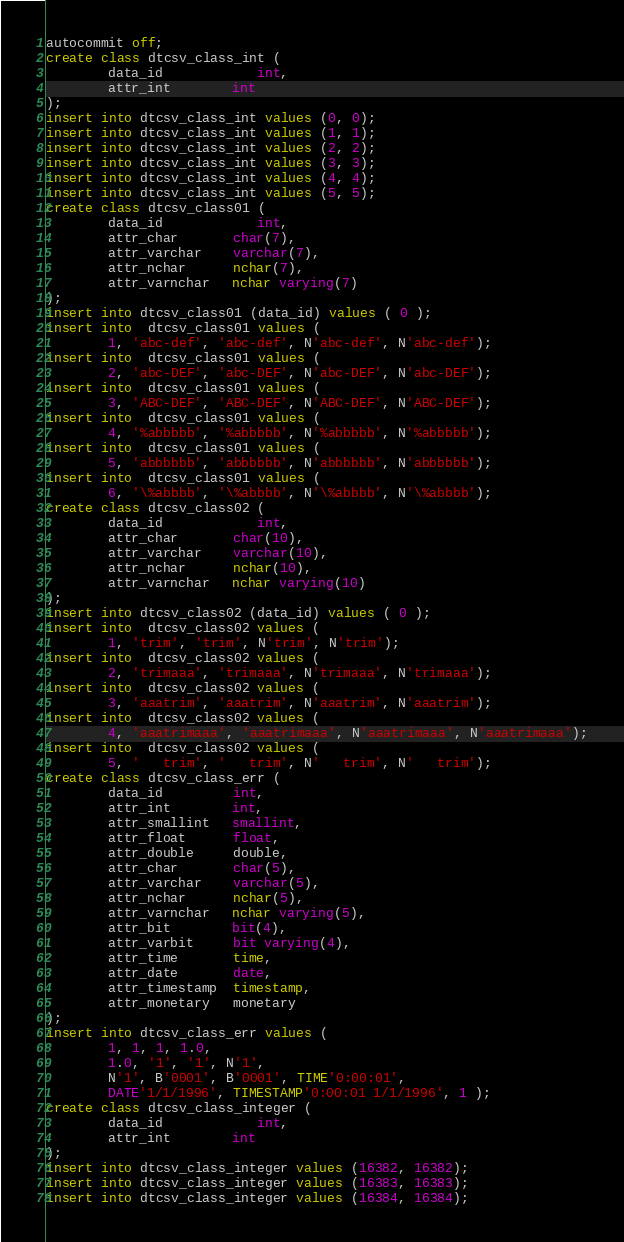Convert code to text. <code><loc_0><loc_0><loc_500><loc_500><_SQL_>autocommit off;
create class dtcsv_class_int (
        data_id        	int,
        attr_int        int
);
insert into dtcsv_class_int values (0, 0);
insert into dtcsv_class_int values (1, 1);
insert into dtcsv_class_int values (2, 2);
insert into dtcsv_class_int values (3, 3);
insert into dtcsv_class_int values (4, 4);
insert into dtcsv_class_int values (5, 5);
create class dtcsv_class01 (
        data_id        	int,
        attr_char       char(7),
        attr_varchar    varchar(7),
        attr_nchar      nchar(7),
        attr_varnchar   nchar varying(7)
);
insert into dtcsv_class01 (data_id) values ( 0 );
insert into  dtcsv_class01 values (
        1, 'abc-def', 'abc-def', N'abc-def', N'abc-def');
insert into  dtcsv_class01 values (
        2, 'abc-DEF', 'abc-DEF', N'abc-DEF', N'abc-DEF');
insert into  dtcsv_class01 values (
        3, 'ABC-DEF', 'ABC-DEF', N'ABC-DEF', N'ABC-DEF');
insert into  dtcsv_class01 values (
        4, '%abbbbb', '%abbbbb', N'%abbbbb', N'%abbbbb');
insert into  dtcsv_class01 values (
        5, 'abbbbbb', 'abbbbbb', N'abbbbbb', N'abbbbbb');
insert into  dtcsv_class01 values (
        6, '\%abbbb', '\%abbbb', N'\%abbbb', N'\%abbbb');
create class dtcsv_class02 (
        data_id        	int,
        attr_char       char(10),
        attr_varchar    varchar(10),
        attr_nchar      nchar(10),
        attr_varnchar   nchar varying(10)
);
insert into dtcsv_class02 (data_id) values ( 0 );
insert into  dtcsv_class02 values (
        1, 'trim', 'trim', N'trim', N'trim');
insert into  dtcsv_class02 values (
        2, 'trimaaa', 'trimaaa', N'trimaaa', N'trimaaa');
insert into  dtcsv_class02 values (
        3, 'aaatrim', 'aaatrim', N'aaatrim', N'aaatrim');
insert into  dtcsv_class02 values (
        4, 'aaatrimaaa', 'aaatrimaaa', N'aaatrimaaa', N'aaatrimaaa');
insert into  dtcsv_class02 values (
        5, '   trim', '   trim', N'   trim', N'   trim');
create class dtcsv_class_err (
        data_id         int,
        attr_int        int,
        attr_smallint   smallint,
        attr_float      float,
        attr_double     double,
        attr_char       char(5),
        attr_varchar    varchar(5),
        attr_nchar      nchar(5),
        attr_varnchar   nchar varying(5),
        attr_bit        bit(4),
        attr_varbit     bit varying(4),
        attr_time       time,
        attr_date       date,
        attr_timestamp  timestamp,
        attr_monetary   monetary
);
insert into dtcsv_class_err values (
        1, 1, 1, 1.0,
        1.0, '1', '1', N'1',
        N'1', B'0001', B'0001', TIME'0:00:01',
        DATE'1/1/1996', TIMESTAMP'0:00:01 1/1/1996', 1 );
create class dtcsv_class_integer (
        data_id        	int,
        attr_int        int
);
insert into dtcsv_class_integer values (16382, 16382);
insert into dtcsv_class_integer values (16383, 16383);
insert into dtcsv_class_integer values (16384, 16384);</code> 